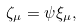<formula> <loc_0><loc_0><loc_500><loc_500>\zeta _ { \mu } = \psi \xi _ { \mu } ,</formula> 